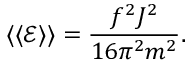Convert formula to latex. <formula><loc_0><loc_0><loc_500><loc_500>\langle \langle { \mathcal { E } } \rangle \rangle = \frac { f ^ { 2 } J ^ { 2 } } { 1 6 \pi ^ { 2 } m ^ { 2 } } .</formula> 